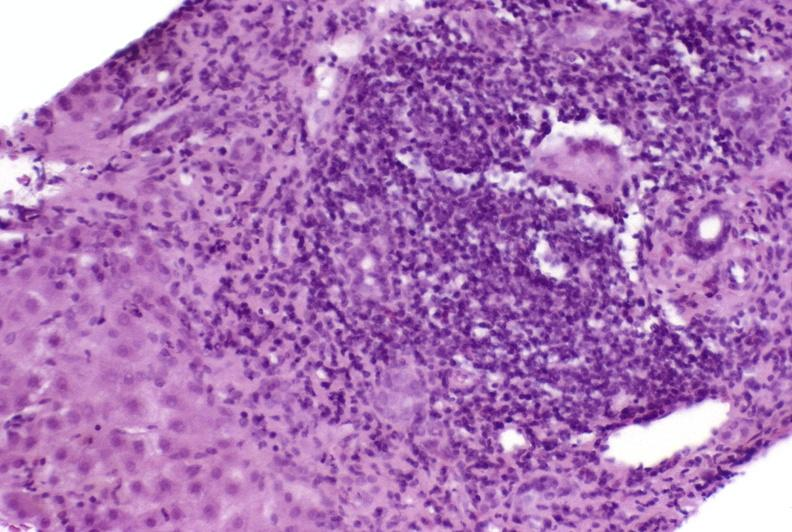what is present?
Answer the question using a single word or phrase. Hepatobiliary 